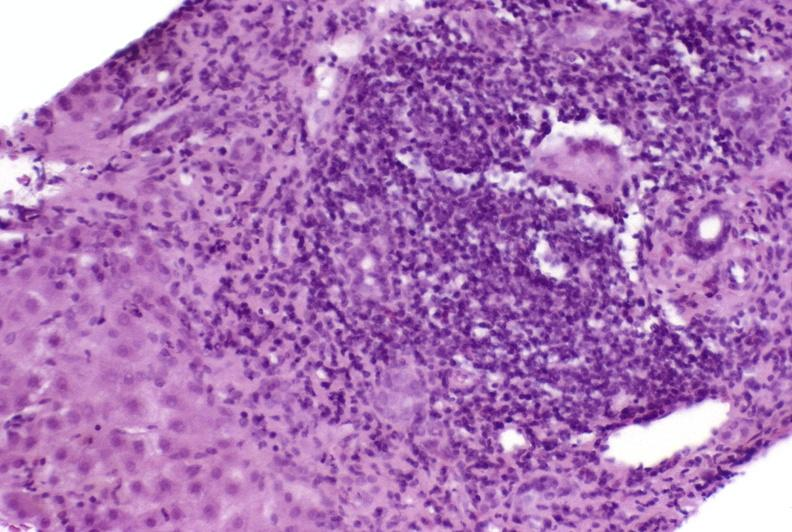what is present?
Answer the question using a single word or phrase. Hepatobiliary 